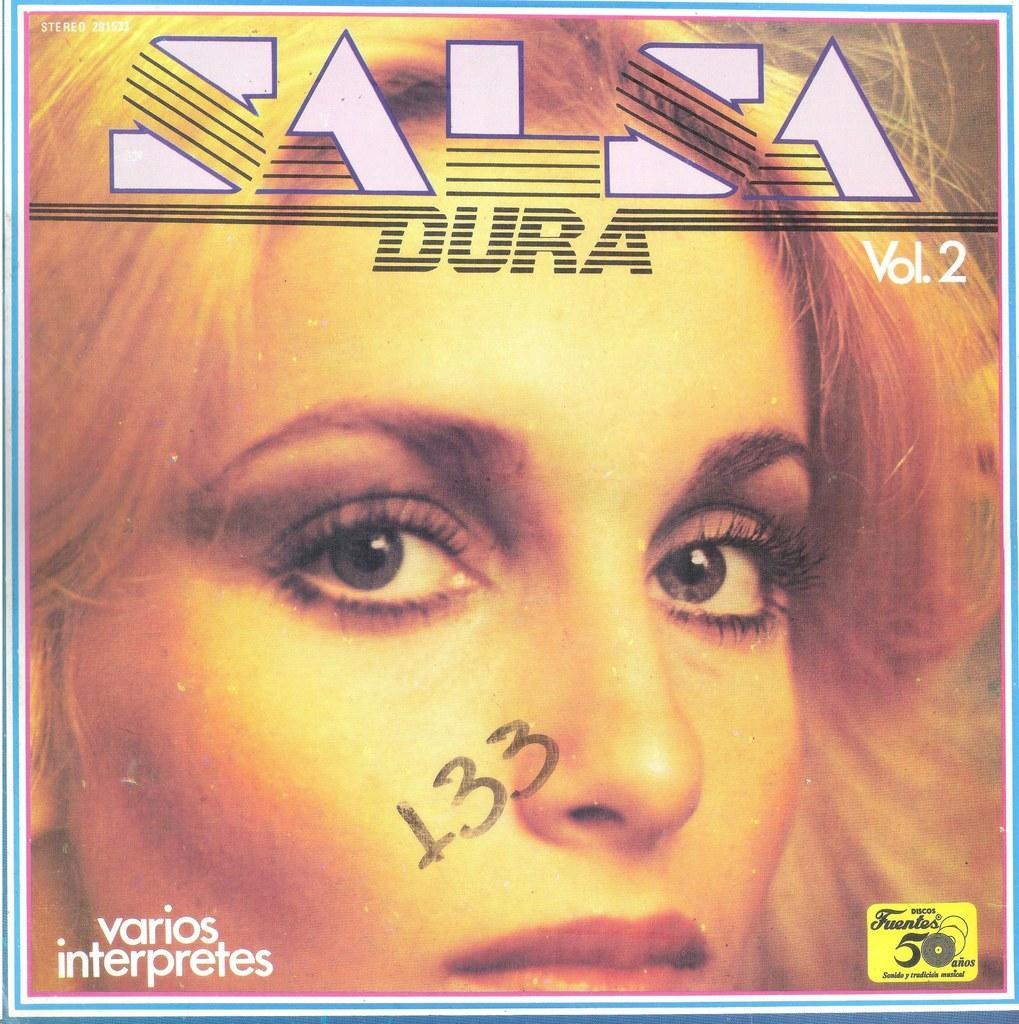<image>
Share a concise interpretation of the image provided. Salsa Dura Vol. 2 is an album that features various artists. 